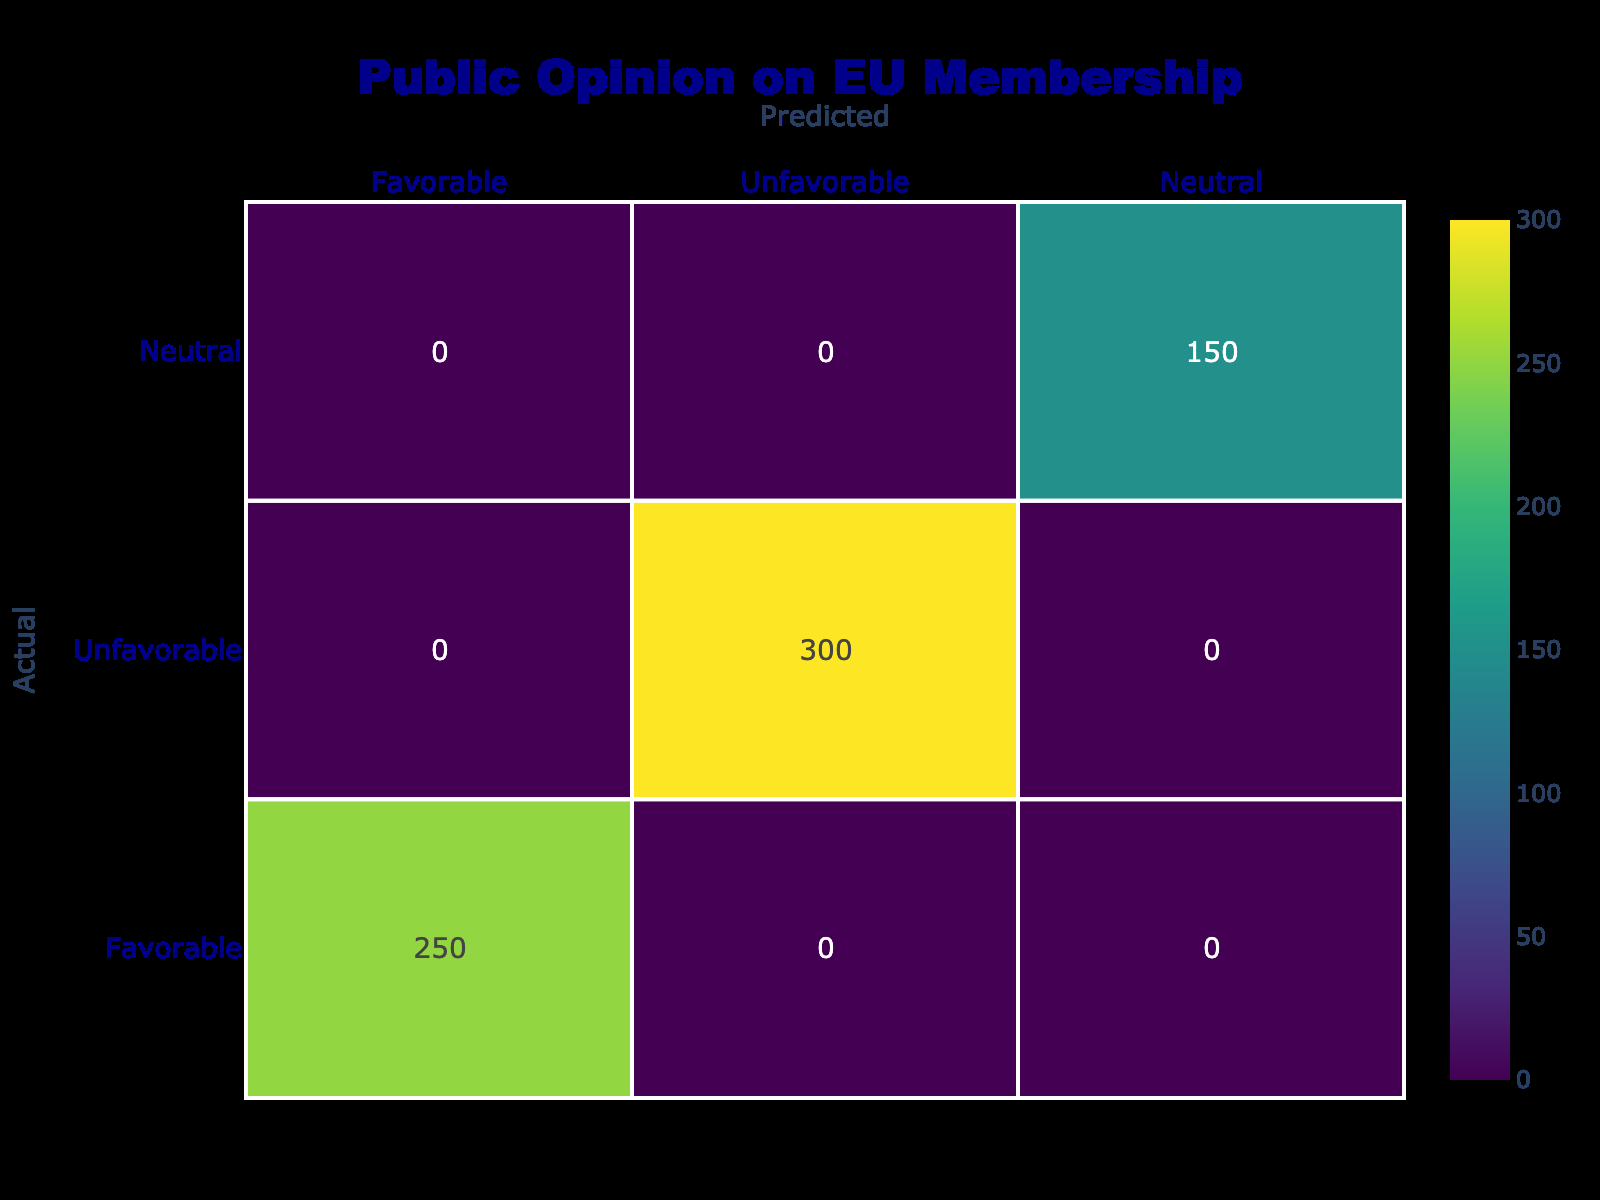What is the total count of respondents with a favorable sentiment? The total count of respondents who have a favorable sentiment is derived from the values provided for each relevant group: Pro-European Campaign (350), Young Adults (300), and Small Business Owners (250). Adding these counts gives us 350 + 300 + 250 = 900.
Answer: 900 How many respondents have an unfavorable sentiment towards EU membership? To find the total count of respondents with an unfavorable sentiment, we tally the values for Older Adults (400), Nationalists (450), and People with Economic Concerns (300). Summing these values gives us 400 + 450 + 300 = 1150.
Answer: 1150 Is the number of respondents with a neutral sentiment greater than the number with a favorable sentiment? The count of neutral respondents is 200 (from Undecided Voters and Educated Professionals), while there are 900 respondents with a favorable sentiment. Since 200 is less than 900, the answer is no.
Answer: No What is the difference between the number of unfavorable and favorable respondents? We first determined the total counts: unfavorable respondents total 1150, while favorable respondents total 900. The difference is calculated by subtracting the favorable from the unfavorable: 1150 - 900 = 250.
Answer: 250 Which group has the highest number of respondents and what is that number? Reviewing the data, the group with the highest number of respondents is Nationalists with a count of 450.
Answer: Nationalists, 450 How many total respondents were surveyed regarding their sentiments towards EU membership? The total count of respondents can be calculated by summing all individual counts: 350 + 300 + 250 + 400 + 450 + 300 + 200 + 150 = 2400.
Answer: 2400 What percentage of respondents expressed an unfavorable sentiment? The percentage of unfavorable respondents is found by taking the unfavorable count (1150) and dividing it by the total count of respondents (2400), then multiplying by 100: (1150/2400) * 100 = 47.92%.
Answer: 47.92% If we combine the counts of Neutral and Favorable sentiments, what is the total? The counts for Neutral (200) and Favorable (900) can be summed as follows: 200 + 900 = 1100, indicating the total number of respondents who are either Neutral or Favorable.
Answer: 1100 Are there more individuals in the Unfavorable category compared to the combined Favorable and Neutral categories? The total for Favorable (900) and Neutral (200) is 1100. The count for Unfavorable is 1150, which is greater: 1150 > 1100. Therefore, yes.
Answer: Yes 